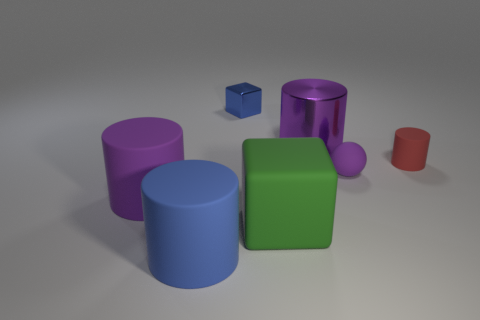Are there any large things of the same color as the ball?
Provide a succinct answer. Yes. There is a big cylinder that is on the right side of the tiny block; is it the same color as the sphere?
Your answer should be compact. Yes. There is a purple matte ball; are there any matte objects behind it?
Keep it short and to the point. Yes. There is a object that is the same color as the small block; what is its material?
Provide a succinct answer. Rubber. Is the material of the cylinder that is to the right of the purple metal cylinder the same as the big green object?
Ensure brevity in your answer.  Yes. There is a cube behind the big matte cylinder behind the big green block; is there a big object that is left of it?
Make the answer very short. Yes. How many spheres are green matte objects or blue rubber objects?
Ensure brevity in your answer.  0. What is the purple object on the right side of the shiny cylinder made of?
Provide a succinct answer. Rubber. What is the size of the matte ball that is the same color as the shiny cylinder?
Make the answer very short. Small. Do the block behind the tiny ball and the big thing that is in front of the big matte cube have the same color?
Provide a short and direct response. Yes. 